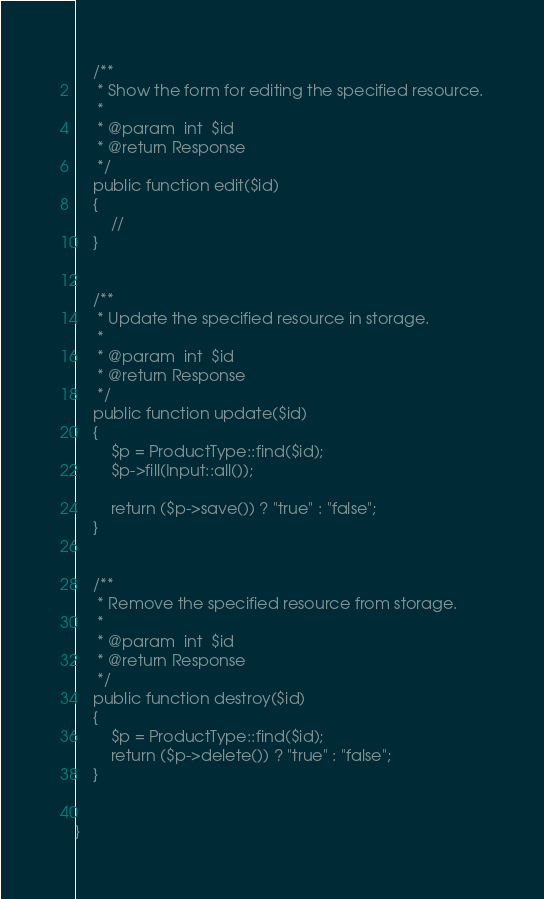<code> <loc_0><loc_0><loc_500><loc_500><_PHP_>	/**
	 * Show the form for editing the specified resource.
	 *
	 * @param  int  $id
	 * @return Response
	 */
	public function edit($id)
	{
		//
	}


	/**
	 * Update the specified resource in storage.
	 *
	 * @param  int  $id
	 * @return Response
	 */
	public function update($id)
	{
		$p = ProductType::find($id);
		$p->fill(Input::all());

		return ($p->save()) ? "true" : "false";
	}


	/**
	 * Remove the specified resource from storage.
	 *
	 * @param  int  $id
	 * @return Response
	 */
	public function destroy($id)
	{
		$p = ProductType::find($id);
		return ($p->delete()) ? "true" : "false";
	}


}
</code> 